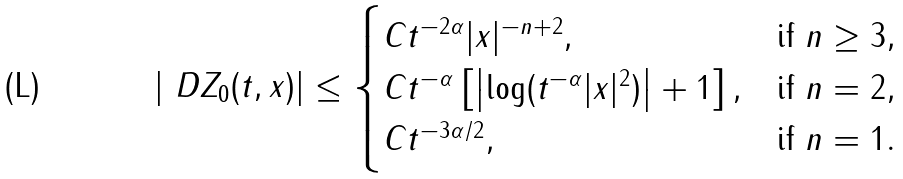<formula> <loc_0><loc_0><loc_500><loc_500>\left | \ D Z _ { 0 } ( t , x ) \right | \leq \begin{cases} C t ^ { - 2 \alpha } | x | ^ { - n + 2 } , & \text {if $n\geq 3$} , \\ C t ^ { - \alpha } \left [ \left | \log ( t ^ { - \alpha } | x | ^ { 2 } ) \right | + 1 \right ] , & \text {if $n=2$} , \\ C t ^ { - 3 \alpha / 2 } , & \text {if $n=1$} . \end{cases}</formula> 